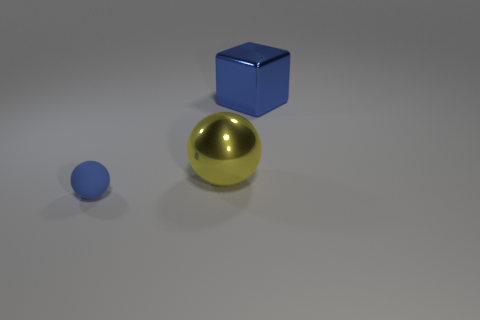Add 3 blue shiny things. How many objects exist? 6 Subtract all balls. How many objects are left? 1 Subtract all small shiny things. Subtract all big shiny things. How many objects are left? 1 Add 3 large objects. How many large objects are left? 5 Add 3 big metal cubes. How many big metal cubes exist? 4 Subtract all blue balls. How many balls are left? 1 Subtract 0 blue cylinders. How many objects are left? 3 Subtract 1 cubes. How many cubes are left? 0 Subtract all purple balls. Subtract all gray blocks. How many balls are left? 2 Subtract all blue spheres. How many yellow cubes are left? 0 